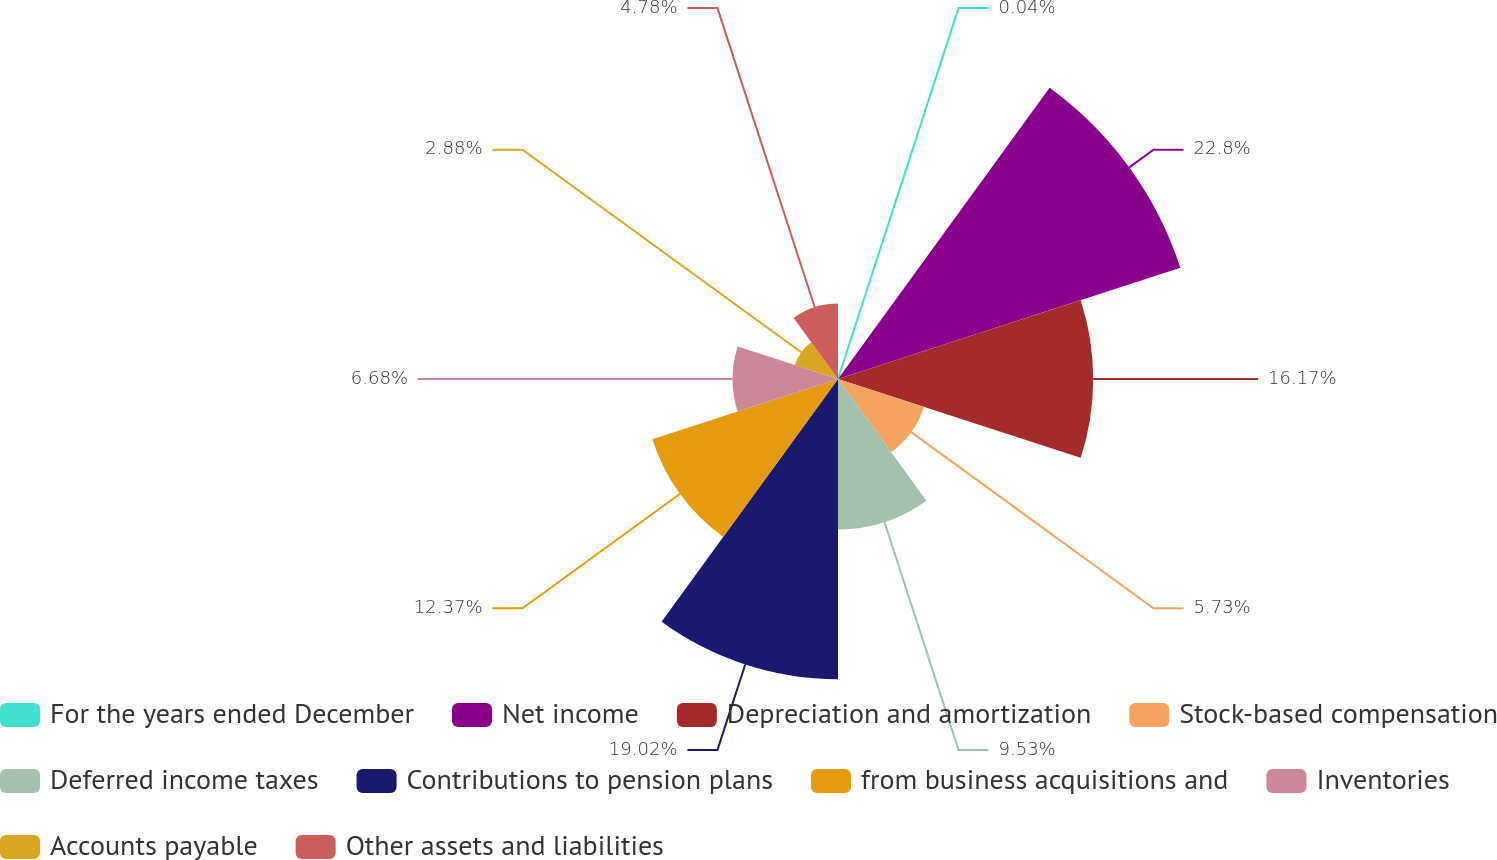Convert chart to OTSL. <chart><loc_0><loc_0><loc_500><loc_500><pie_chart><fcel>For the years ended December<fcel>Net income<fcel>Depreciation and amortization<fcel>Stock-based compensation<fcel>Deferred income taxes<fcel>Contributions to pension plans<fcel>from business acquisitions and<fcel>Inventories<fcel>Accounts payable<fcel>Other assets and liabilities<nl><fcel>0.04%<fcel>22.81%<fcel>16.17%<fcel>5.73%<fcel>9.53%<fcel>19.02%<fcel>12.37%<fcel>6.68%<fcel>2.88%<fcel>4.78%<nl></chart> 